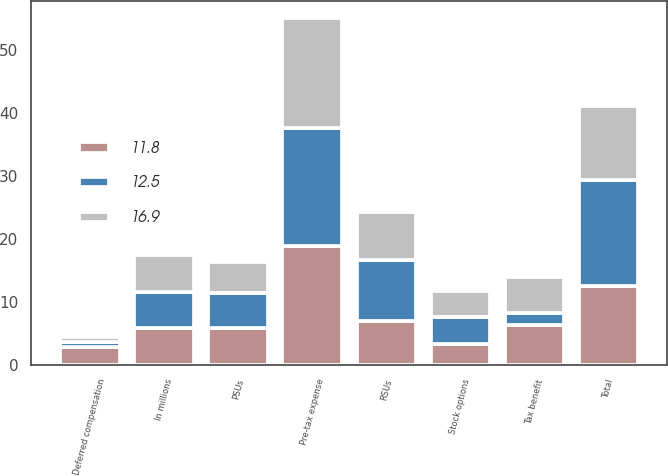<chart> <loc_0><loc_0><loc_500><loc_500><stacked_bar_chart><ecel><fcel>In millions<fcel>Stock options<fcel>RSUs<fcel>PSUs<fcel>Deferred compensation<fcel>Pre-tax expense<fcel>Tax benefit<fcel>Total<nl><fcel>12.5<fcel>5.8<fcel>4.3<fcel>9.6<fcel>5.7<fcel>0.8<fcel>18.8<fcel>1.9<fcel>16.9<nl><fcel>11.8<fcel>5.8<fcel>3.3<fcel>7<fcel>5.8<fcel>2.8<fcel>18.9<fcel>6.4<fcel>12.5<nl><fcel>16.9<fcel>5.8<fcel>4.1<fcel>7.7<fcel>4.8<fcel>0.8<fcel>17.4<fcel>5.6<fcel>11.8<nl></chart> 